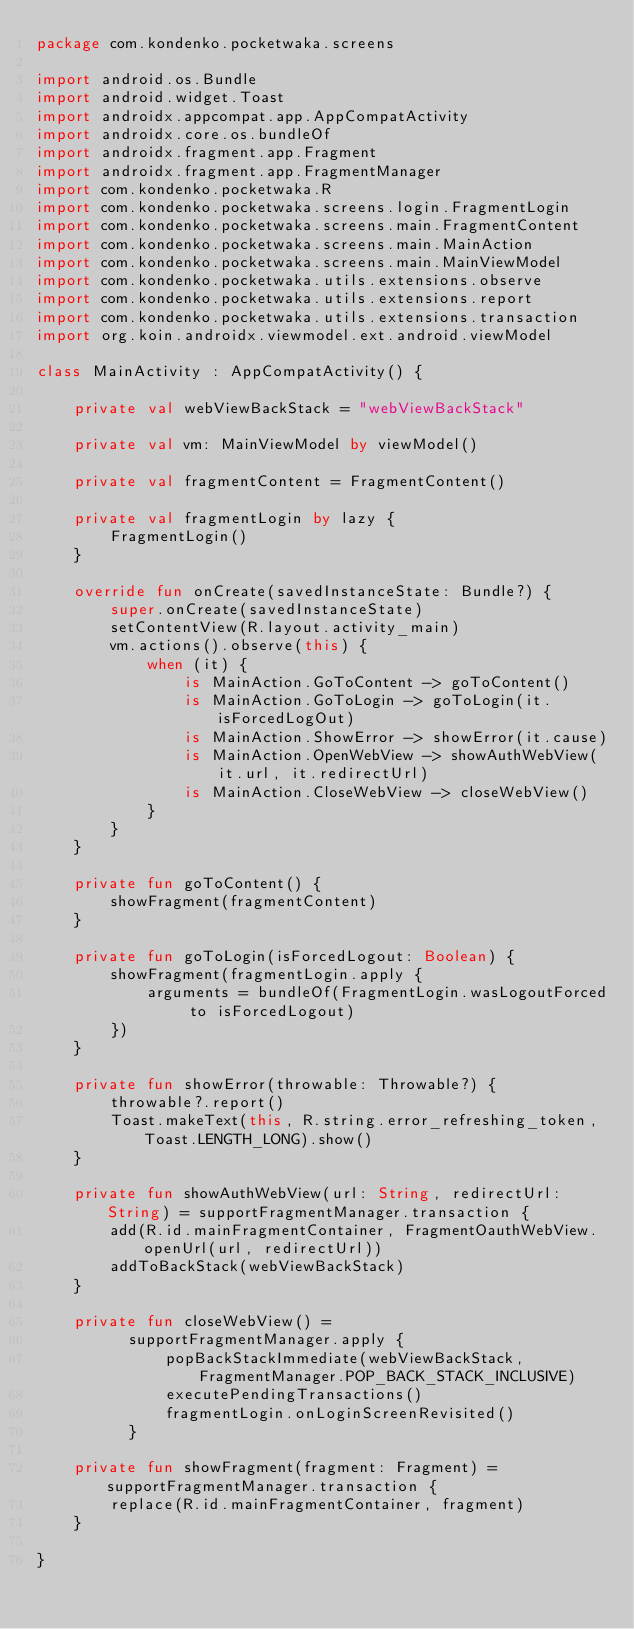<code> <loc_0><loc_0><loc_500><loc_500><_Kotlin_>package com.kondenko.pocketwaka.screens

import android.os.Bundle
import android.widget.Toast
import androidx.appcompat.app.AppCompatActivity
import androidx.core.os.bundleOf
import androidx.fragment.app.Fragment
import androidx.fragment.app.FragmentManager
import com.kondenko.pocketwaka.R
import com.kondenko.pocketwaka.screens.login.FragmentLogin
import com.kondenko.pocketwaka.screens.main.FragmentContent
import com.kondenko.pocketwaka.screens.main.MainAction
import com.kondenko.pocketwaka.screens.main.MainViewModel
import com.kondenko.pocketwaka.utils.extensions.observe
import com.kondenko.pocketwaka.utils.extensions.report
import com.kondenko.pocketwaka.utils.extensions.transaction
import org.koin.androidx.viewmodel.ext.android.viewModel

class MainActivity : AppCompatActivity() {

    private val webViewBackStack = "webViewBackStack"

    private val vm: MainViewModel by viewModel()

    private val fragmentContent = FragmentContent()

    private val fragmentLogin by lazy {
        FragmentLogin()
    }

    override fun onCreate(savedInstanceState: Bundle?) {
        super.onCreate(savedInstanceState)
        setContentView(R.layout.activity_main)
        vm.actions().observe(this) {
            when (it) {
                is MainAction.GoToContent -> goToContent()
                is MainAction.GoToLogin -> goToLogin(it.isForcedLogOut)
                is MainAction.ShowError -> showError(it.cause)
                is MainAction.OpenWebView -> showAuthWebView(it.url, it.redirectUrl)
                is MainAction.CloseWebView -> closeWebView()
            }
        }
    }

    private fun goToContent() {
        showFragment(fragmentContent)
    }

    private fun goToLogin(isForcedLogout: Boolean) {
        showFragment(fragmentLogin.apply {
            arguments = bundleOf(FragmentLogin.wasLogoutForced to isForcedLogout)
        })
    }

    private fun showError(throwable: Throwable?) {
        throwable?.report()
        Toast.makeText(this, R.string.error_refreshing_token, Toast.LENGTH_LONG).show()
    }

    private fun showAuthWebView(url: String, redirectUrl: String) = supportFragmentManager.transaction {
        add(R.id.mainFragmentContainer, FragmentOauthWebView.openUrl(url, redirectUrl))
        addToBackStack(webViewBackStack)
    }

    private fun closeWebView() =
          supportFragmentManager.apply {
              popBackStackImmediate(webViewBackStack, FragmentManager.POP_BACK_STACK_INCLUSIVE)
              executePendingTransactions()
              fragmentLogin.onLoginScreenRevisited()
          }

    private fun showFragment(fragment: Fragment) = supportFragmentManager.transaction {
        replace(R.id.mainFragmentContainer, fragment)
    }

}
</code> 